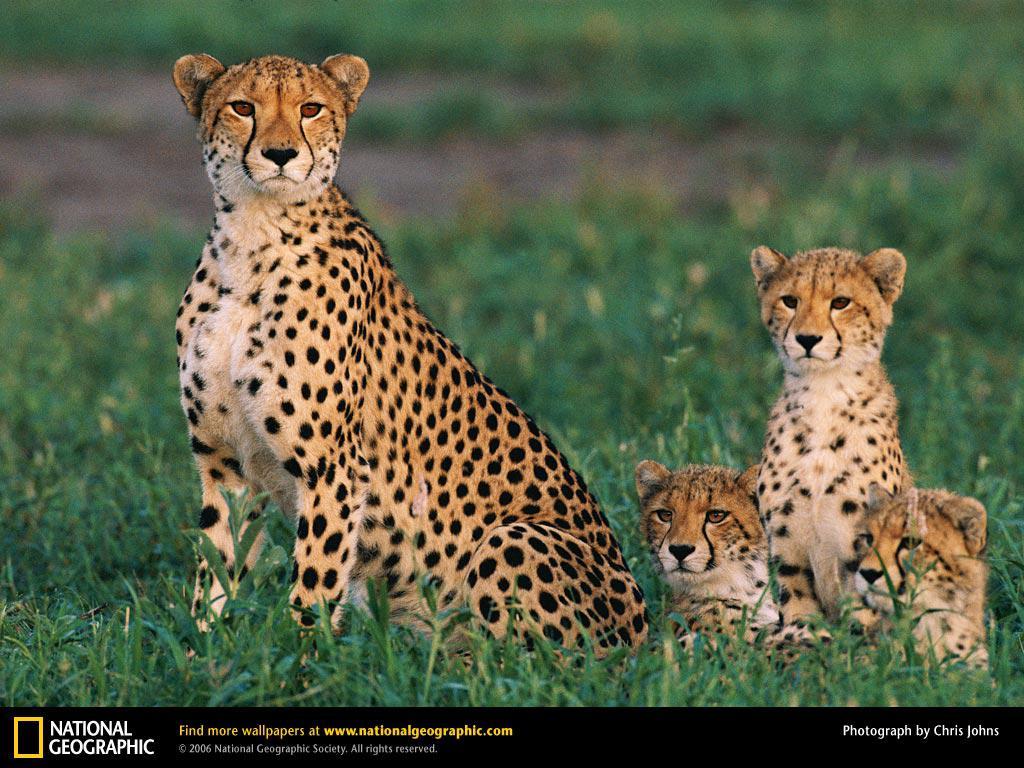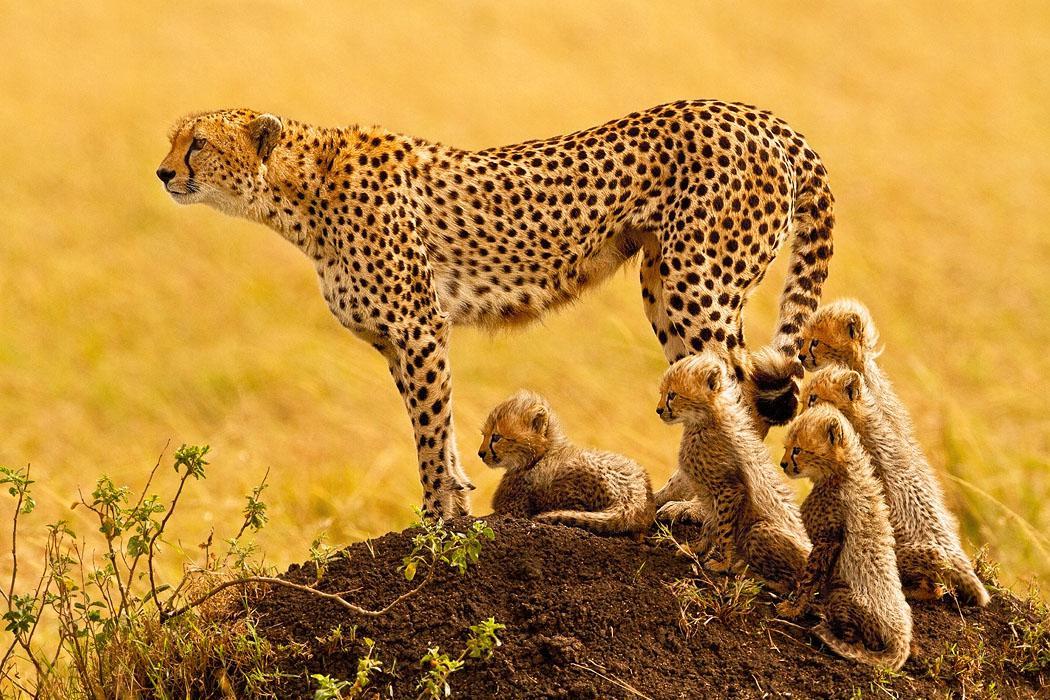The first image is the image on the left, the second image is the image on the right. Evaluate the accuracy of this statement regarding the images: "The right image contains half as many cheetahs as the left image.". Is it true? Answer yes or no. No. The first image is the image on the left, the second image is the image on the right. Considering the images on both sides, is "The left image contains exactly two cheetahs." valid? Answer yes or no. No. 